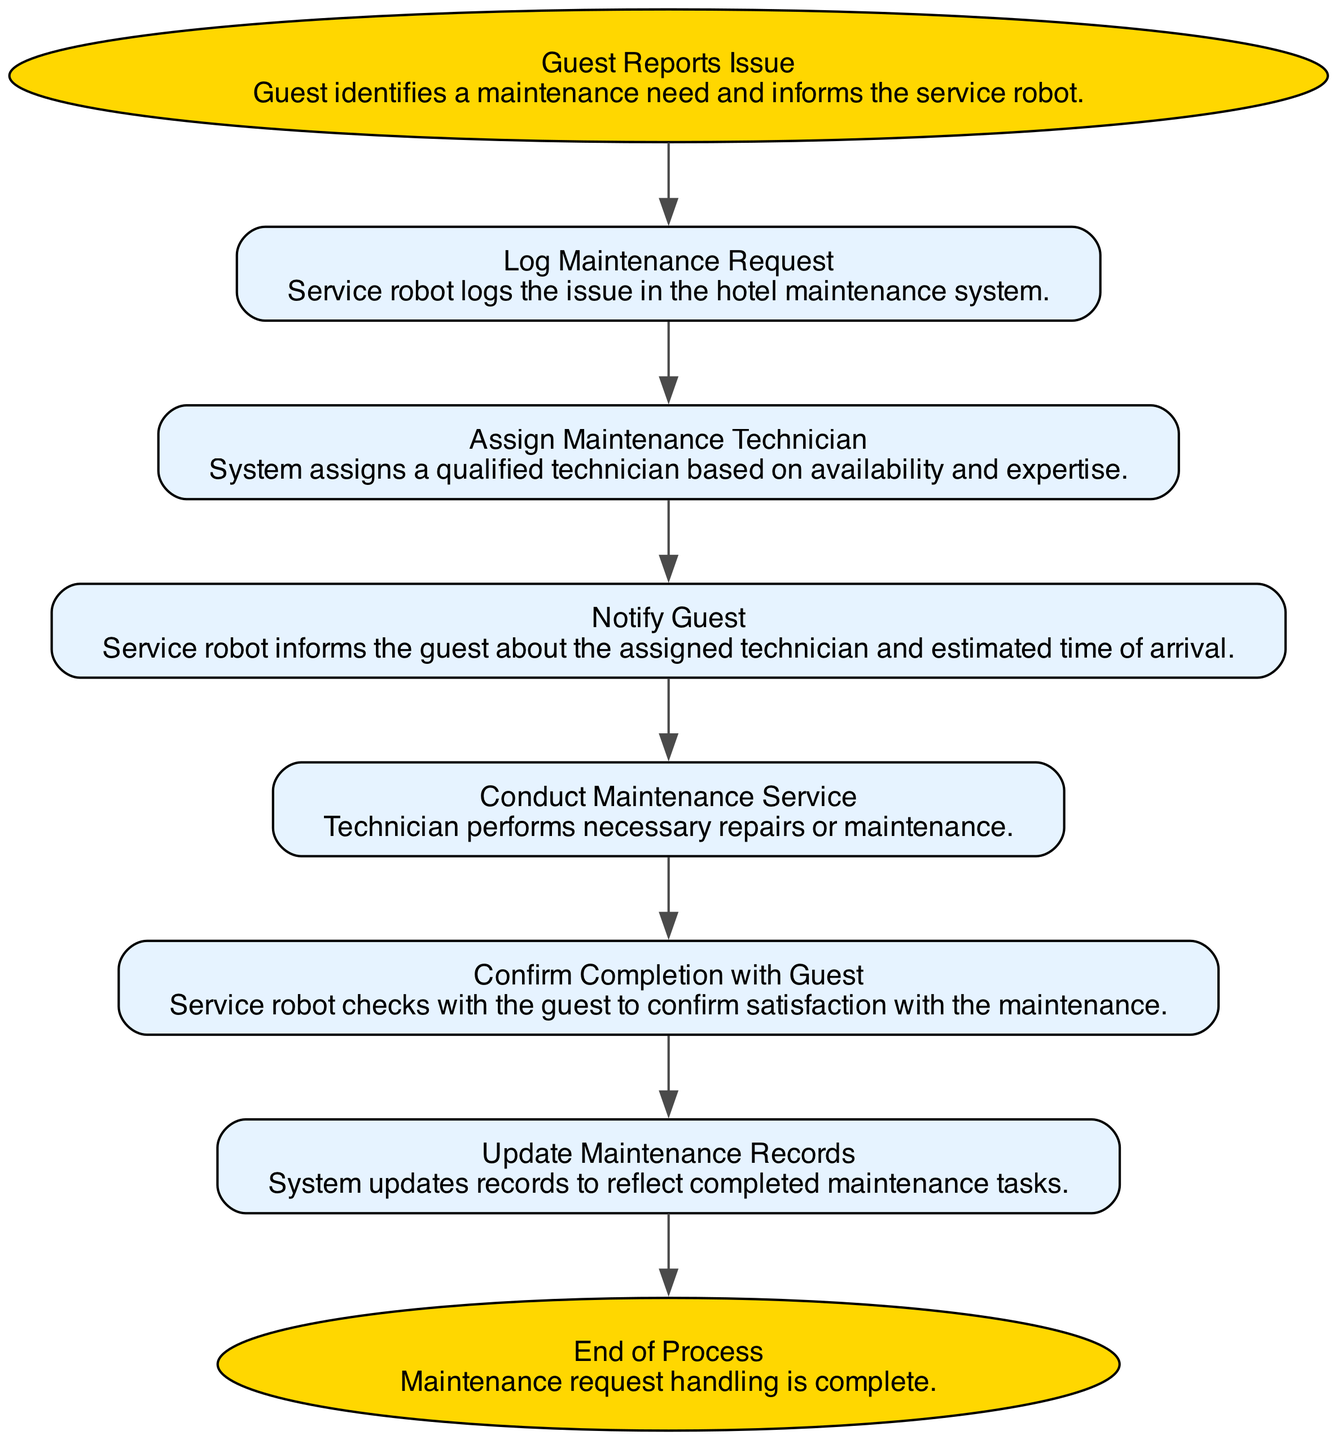What is the first step after a guest reports an issue? The first step in the diagram is to log the maintenance request, which is indicated as the second element in the flow, following the guest's report of the issue.
Answer: Log Maintenance Request How many steps are there in the process? Counting all unique elements in the flow, there are a total of seven distinct steps: starting from "Guest Reports Issue" to "End of Process."
Answer: Seven What does the service robot do after assigning a maintenance technician? After the technician is assigned, the service robot notifies the guest about the assigned technician and the estimated time of arrival, which is the next step in the flow.
Answer: Notify Guest Which step confirms the completion of maintenance? The step where confirmation of completion with the guest occurs is labeled "Confirm Completion with Guest," which follows the conducting of maintenance.
Answer: Confirm Completion with Guest What type of flow is depicted in this diagram? The diagram illustrates a flow chart that shows a sequential process for handling maintenance requests from guests, depicting the order of operations clearly.
Answer: Flow Chart 